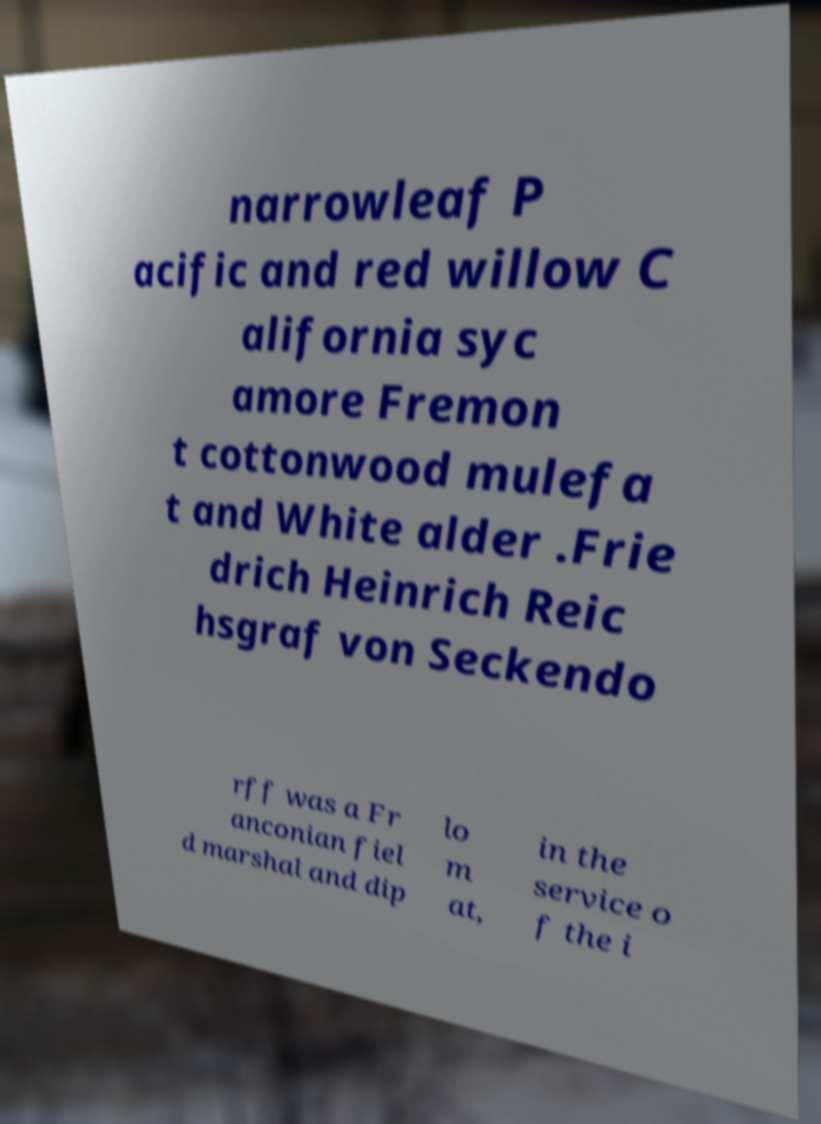There's text embedded in this image that I need extracted. Can you transcribe it verbatim? narrowleaf P acific and red willow C alifornia syc amore Fremon t cottonwood mulefa t and White alder .Frie drich Heinrich Reic hsgraf von Seckendo rff was a Fr anconian fiel d marshal and dip lo m at, in the service o f the i 